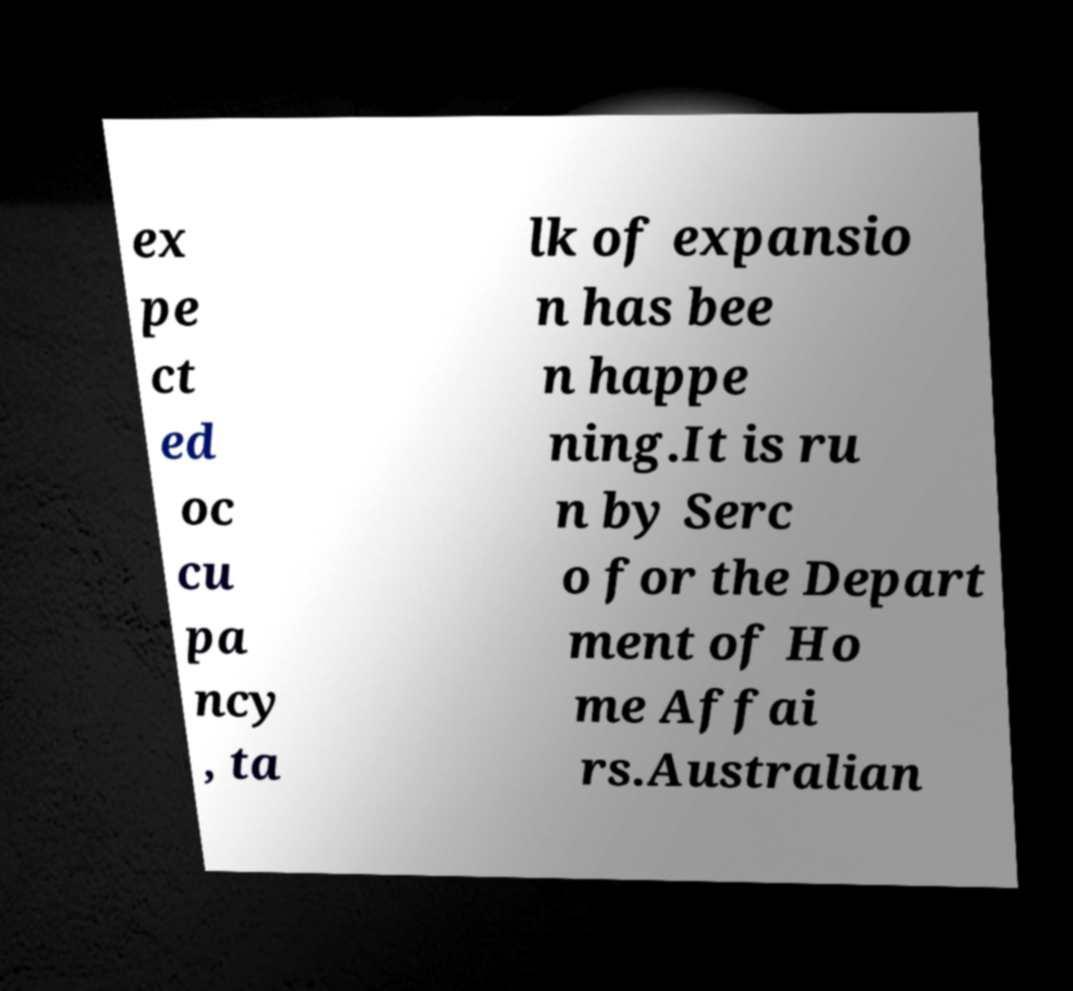Please identify and transcribe the text found in this image. ex pe ct ed oc cu pa ncy , ta lk of expansio n has bee n happe ning.It is ru n by Serc o for the Depart ment of Ho me Affai rs.Australian 